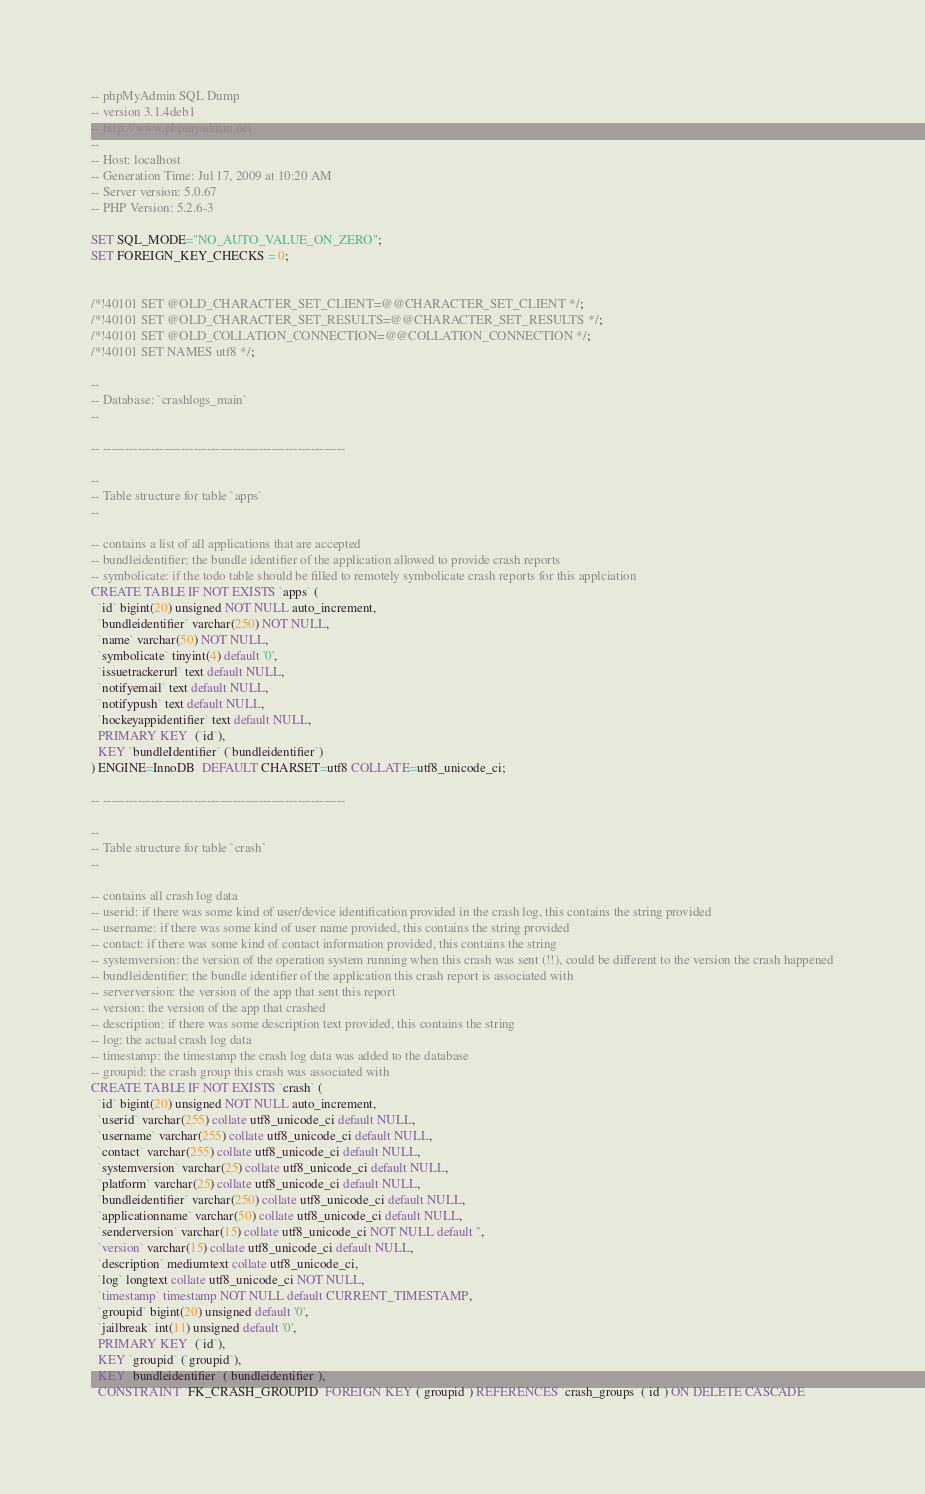Convert code to text. <code><loc_0><loc_0><loc_500><loc_500><_SQL_>-- phpMyAdmin SQL Dump
-- version 3.1.4deb1
-- http://www.phpmyadmin.net
--
-- Host: localhost
-- Generation Time: Jul 17, 2009 at 10:20 AM
-- Server version: 5.0.67
-- PHP Version: 5.2.6-3

SET SQL_MODE="NO_AUTO_VALUE_ON_ZERO";
SET FOREIGN_KEY_CHECKS = 0;


/*!40101 SET @OLD_CHARACTER_SET_CLIENT=@@CHARACTER_SET_CLIENT */;
/*!40101 SET @OLD_CHARACTER_SET_RESULTS=@@CHARACTER_SET_RESULTS */;
/*!40101 SET @OLD_COLLATION_CONNECTION=@@COLLATION_CONNECTION */;
/*!40101 SET NAMES utf8 */;

--
-- Database: `crashlogs_main`
--

-- --------------------------------------------------------

--
-- Table structure for table `apps`
--

-- contains a list of all applications that are accepted
-- bundleidentifier: the bundle identifier of the application allowed to provide crash reports
-- symbolicate: if the todo table should be filled to remotely symbolicate crash reports for this applciation
CREATE TABLE IF NOT EXISTS `apps` (
  `id` bigint(20) unsigned NOT NULL auto_increment,
  `bundleidentifier` varchar(250) NOT NULL,
  `name` varchar(50) NOT NULL,
  `symbolicate` tinyint(4) default '0',
  `issuetrackerurl` text default NULL,
  `notifyemail` text default NULL,
  `notifypush` text default NULL,
  `hockeyappidentifier` text default NULL,
  PRIMARY KEY  (`id`),
  KEY `bundleIdentifier` (`bundleidentifier`)
) ENGINE=InnoDB  DEFAULT CHARSET=utf8 COLLATE=utf8_unicode_ci;

-- --------------------------------------------------------

--
-- Table structure for table `crash`
--

-- contains all crash log data
-- userid: if there was some kind of user/device identification provided in the crash log, this contains the string provided
-- username: if there was some kind of user name provided, this contains the string provided
-- contact: if there was some kind of contact information provided, this contains the string
-- systemversion: the version of the operation system running when this crash was sent (!!), could be different to the version the crash happened
-- bundleidentifier: the bundle identifier of the application this crash report is associated with
-- serverversion: the version of the app that sent this report
-- version: the version of the app that crashed
-- description: if there was some description text provided, this contains the string
-- log: the actual crash log data
-- timestamp: the timestamp the crash log data was added to the database
-- groupid: the crash group this crash was associated with
CREATE TABLE IF NOT EXISTS `crash` (
  `id` bigint(20) unsigned NOT NULL auto_increment,
  `userid` varchar(255) collate utf8_unicode_ci default NULL,
  `username` varchar(255) collate utf8_unicode_ci default NULL,
  `contact` varchar(255) collate utf8_unicode_ci default NULL,
  `systemversion` varchar(25) collate utf8_unicode_ci default NULL,
  `platform` varchar(25) collate utf8_unicode_ci default NULL,
  `bundleidentifier` varchar(250) collate utf8_unicode_ci default NULL,
  `applicationname` varchar(50) collate utf8_unicode_ci default NULL,
  `senderversion` varchar(15) collate utf8_unicode_ci NOT NULL default '',
  `version` varchar(15) collate utf8_unicode_ci default NULL,
  `description` mediumtext collate utf8_unicode_ci,
  `log` longtext collate utf8_unicode_ci NOT NULL,
  `timestamp` timestamp NOT NULL default CURRENT_TIMESTAMP,
  `groupid` bigint(20) unsigned default '0',
  `jailbreak` int(11) unsigned default '0',
  PRIMARY KEY  (`id`),
  KEY `groupid` (`groupid`),
  KEY `bundleidentifier` (`bundleidentifier`),
  CONSTRAINT `FK_CRASH_GROUPID` FOREIGN KEY (`groupid`) REFERENCES `crash_groups` (`id`) ON DELETE CASCADE</code> 